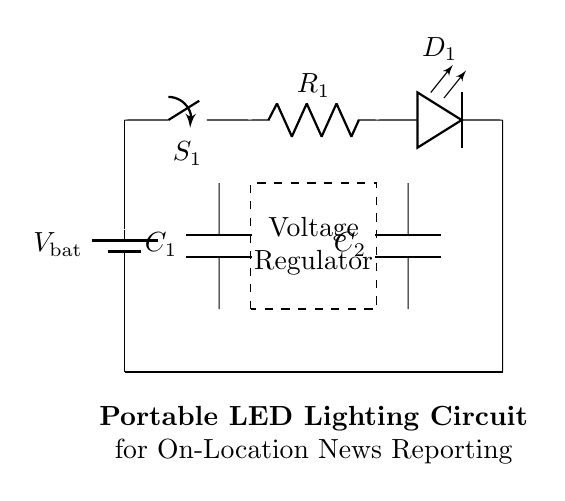What is the main power source in this circuit? The circuit uses a battery as its main power source, as indicated by the symbol marked with "V bat" at the beginning of the circuit.
Answer: battery What component is responsible for regulating voltage? The circuit includes a voltage regulator, which is represented by a dashed rectangle in the diagram and labeled accordingly.
Answer: Voltage regulator How many capacitors are present in the circuit? There are two capacitors shown in the circuit; they are labeled C 1 and C 2, one in the dashed box for the voltage regulator and the other near the LED.
Answer: two What is the role of the resistor in this circuit? The resistor labeled R 1 is needed to limit the current flowing to the LED, protecting it from excessive current that might cause damage.
Answer: Current limiter Which component is used for illumination? The LED labeled D 1 is the component specifically designed to emit light when current passes through it, making it the primary illumination source in the circuit.
Answer: LED What happens when switch S 1 is closed? Closing switch S 1 allows current to flow from the battery through the circuit, energizing the LED and making it light up, indicating that the circuit is complete.
Answer: LED lights up What is the purpose of the capacitors in this circuit? The capacitors C 1 and C 2 serve to stabilize the voltage output and smoothen fluctuations, ensuring a steady supply of power to the LED and the rest of the circuit.
Answer: Voltage stabilization 